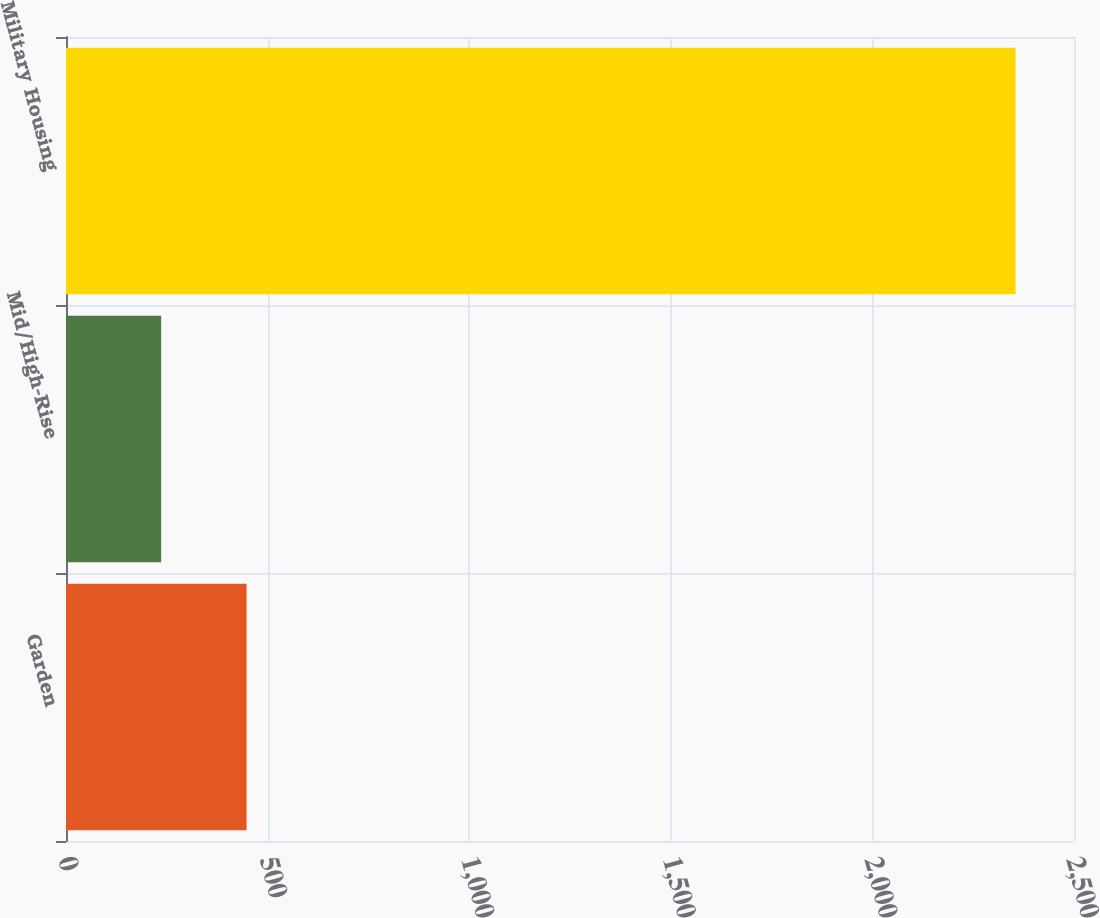Convert chart to OTSL. <chart><loc_0><loc_0><loc_500><loc_500><bar_chart><fcel>Garden<fcel>Mid/High-Rise<fcel>Military Housing<nl><fcel>447.9<fcel>236<fcel>2355<nl></chart> 